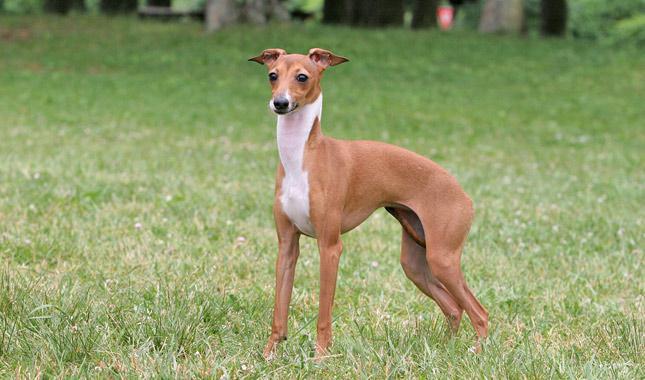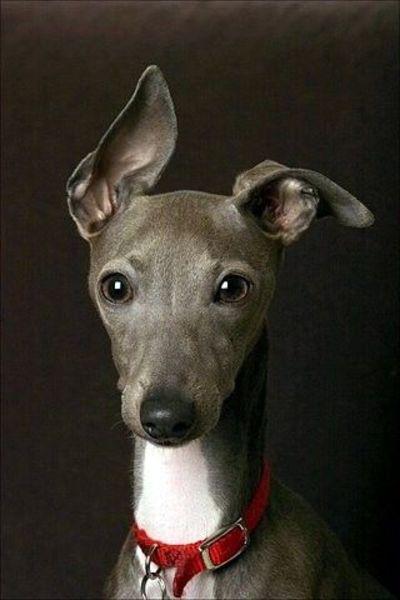The first image is the image on the left, the second image is the image on the right. Examine the images to the left and right. Is the description "There is grass visible in one of the images." accurate? Answer yes or no. Yes. The first image is the image on the left, the second image is the image on the right. Assess this claim about the two images: "One dog is in grass.". Correct or not? Answer yes or no. Yes. 